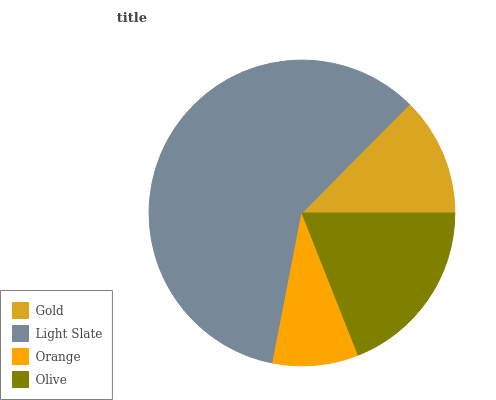Is Orange the minimum?
Answer yes or no. Yes. Is Light Slate the maximum?
Answer yes or no. Yes. Is Light Slate the minimum?
Answer yes or no. No. Is Orange the maximum?
Answer yes or no. No. Is Light Slate greater than Orange?
Answer yes or no. Yes. Is Orange less than Light Slate?
Answer yes or no. Yes. Is Orange greater than Light Slate?
Answer yes or no. No. Is Light Slate less than Orange?
Answer yes or no. No. Is Olive the high median?
Answer yes or no. Yes. Is Gold the low median?
Answer yes or no. Yes. Is Gold the high median?
Answer yes or no. No. Is Olive the low median?
Answer yes or no. No. 